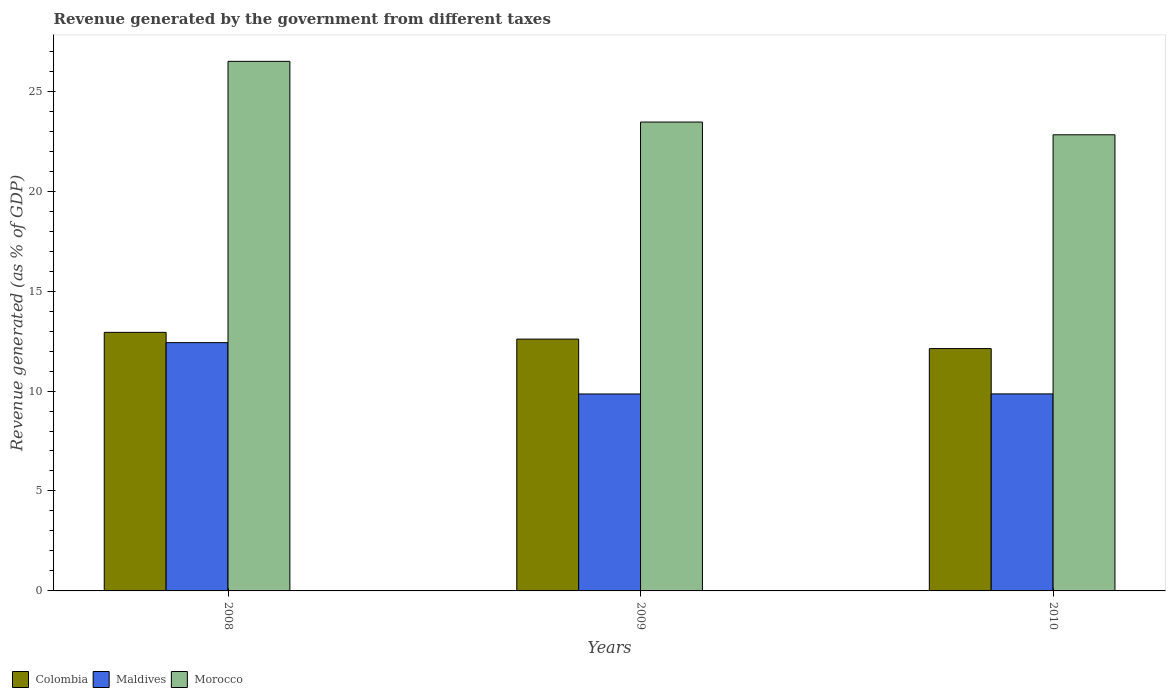How many different coloured bars are there?
Your answer should be very brief. 3. How many bars are there on the 2nd tick from the left?
Offer a very short reply. 3. How many bars are there on the 1st tick from the right?
Give a very brief answer. 3. What is the label of the 3rd group of bars from the left?
Your answer should be compact. 2010. In how many cases, is the number of bars for a given year not equal to the number of legend labels?
Ensure brevity in your answer.  0. What is the revenue generated by the government in Colombia in 2008?
Give a very brief answer. 12.94. Across all years, what is the maximum revenue generated by the government in Colombia?
Provide a short and direct response. 12.94. Across all years, what is the minimum revenue generated by the government in Morocco?
Your answer should be very brief. 22.82. What is the total revenue generated by the government in Morocco in the graph?
Offer a very short reply. 72.77. What is the difference between the revenue generated by the government in Colombia in 2008 and that in 2010?
Keep it short and to the point. 0.81. What is the difference between the revenue generated by the government in Morocco in 2008 and the revenue generated by the government in Maldives in 2009?
Give a very brief answer. 16.64. What is the average revenue generated by the government in Colombia per year?
Keep it short and to the point. 12.55. In the year 2010, what is the difference between the revenue generated by the government in Morocco and revenue generated by the government in Maldives?
Make the answer very short. 12.96. What is the ratio of the revenue generated by the government in Colombia in 2009 to that in 2010?
Your answer should be very brief. 1.04. Is the difference between the revenue generated by the government in Morocco in 2009 and 2010 greater than the difference between the revenue generated by the government in Maldives in 2009 and 2010?
Provide a short and direct response. Yes. What is the difference between the highest and the second highest revenue generated by the government in Morocco?
Your response must be concise. 3.04. What is the difference between the highest and the lowest revenue generated by the government in Morocco?
Keep it short and to the point. 3.67. What does the 2nd bar from the left in 2009 represents?
Provide a succinct answer. Maldives. What does the 1st bar from the right in 2009 represents?
Your response must be concise. Morocco. Is it the case that in every year, the sum of the revenue generated by the government in Maldives and revenue generated by the government in Colombia is greater than the revenue generated by the government in Morocco?
Provide a succinct answer. No. How many bars are there?
Your response must be concise. 9. Does the graph contain grids?
Provide a succinct answer. No. How many legend labels are there?
Make the answer very short. 3. What is the title of the graph?
Provide a succinct answer. Revenue generated by the government from different taxes. Does "St. Vincent and the Grenadines" appear as one of the legend labels in the graph?
Your response must be concise. No. What is the label or title of the Y-axis?
Your answer should be compact. Revenue generated (as % of GDP). What is the Revenue generated (as % of GDP) in Colombia in 2008?
Provide a short and direct response. 12.94. What is the Revenue generated (as % of GDP) in Maldives in 2008?
Offer a very short reply. 12.42. What is the Revenue generated (as % of GDP) in Morocco in 2008?
Provide a succinct answer. 26.49. What is the Revenue generated (as % of GDP) in Colombia in 2009?
Give a very brief answer. 12.6. What is the Revenue generated (as % of GDP) of Maldives in 2009?
Your answer should be compact. 9.85. What is the Revenue generated (as % of GDP) of Morocco in 2009?
Your answer should be very brief. 23.46. What is the Revenue generated (as % of GDP) in Colombia in 2010?
Provide a short and direct response. 12.12. What is the Revenue generated (as % of GDP) of Maldives in 2010?
Offer a very short reply. 9.86. What is the Revenue generated (as % of GDP) of Morocco in 2010?
Your answer should be compact. 22.82. Across all years, what is the maximum Revenue generated (as % of GDP) of Colombia?
Offer a terse response. 12.94. Across all years, what is the maximum Revenue generated (as % of GDP) of Maldives?
Provide a short and direct response. 12.42. Across all years, what is the maximum Revenue generated (as % of GDP) in Morocco?
Your answer should be compact. 26.49. Across all years, what is the minimum Revenue generated (as % of GDP) in Colombia?
Your response must be concise. 12.12. Across all years, what is the minimum Revenue generated (as % of GDP) in Maldives?
Offer a very short reply. 9.85. Across all years, what is the minimum Revenue generated (as % of GDP) in Morocco?
Offer a terse response. 22.82. What is the total Revenue generated (as % of GDP) of Colombia in the graph?
Your answer should be compact. 37.66. What is the total Revenue generated (as % of GDP) of Maldives in the graph?
Provide a short and direct response. 32.13. What is the total Revenue generated (as % of GDP) in Morocco in the graph?
Offer a terse response. 72.77. What is the difference between the Revenue generated (as % of GDP) in Colombia in 2008 and that in 2009?
Your answer should be compact. 0.34. What is the difference between the Revenue generated (as % of GDP) in Maldives in 2008 and that in 2009?
Give a very brief answer. 2.57. What is the difference between the Revenue generated (as % of GDP) of Morocco in 2008 and that in 2009?
Make the answer very short. 3.04. What is the difference between the Revenue generated (as % of GDP) in Colombia in 2008 and that in 2010?
Ensure brevity in your answer.  0.81. What is the difference between the Revenue generated (as % of GDP) of Maldives in 2008 and that in 2010?
Offer a terse response. 2.56. What is the difference between the Revenue generated (as % of GDP) in Morocco in 2008 and that in 2010?
Give a very brief answer. 3.67. What is the difference between the Revenue generated (as % of GDP) of Colombia in 2009 and that in 2010?
Your answer should be compact. 0.48. What is the difference between the Revenue generated (as % of GDP) in Maldives in 2009 and that in 2010?
Provide a succinct answer. -0. What is the difference between the Revenue generated (as % of GDP) in Morocco in 2009 and that in 2010?
Ensure brevity in your answer.  0.64. What is the difference between the Revenue generated (as % of GDP) of Colombia in 2008 and the Revenue generated (as % of GDP) of Maldives in 2009?
Provide a succinct answer. 3.08. What is the difference between the Revenue generated (as % of GDP) in Colombia in 2008 and the Revenue generated (as % of GDP) in Morocco in 2009?
Keep it short and to the point. -10.52. What is the difference between the Revenue generated (as % of GDP) of Maldives in 2008 and the Revenue generated (as % of GDP) of Morocco in 2009?
Your answer should be compact. -11.04. What is the difference between the Revenue generated (as % of GDP) of Colombia in 2008 and the Revenue generated (as % of GDP) of Maldives in 2010?
Make the answer very short. 3.08. What is the difference between the Revenue generated (as % of GDP) of Colombia in 2008 and the Revenue generated (as % of GDP) of Morocco in 2010?
Your response must be concise. -9.88. What is the difference between the Revenue generated (as % of GDP) of Maldives in 2008 and the Revenue generated (as % of GDP) of Morocco in 2010?
Keep it short and to the point. -10.4. What is the difference between the Revenue generated (as % of GDP) in Colombia in 2009 and the Revenue generated (as % of GDP) in Maldives in 2010?
Your answer should be very brief. 2.74. What is the difference between the Revenue generated (as % of GDP) of Colombia in 2009 and the Revenue generated (as % of GDP) of Morocco in 2010?
Keep it short and to the point. -10.22. What is the difference between the Revenue generated (as % of GDP) of Maldives in 2009 and the Revenue generated (as % of GDP) of Morocco in 2010?
Provide a succinct answer. -12.97. What is the average Revenue generated (as % of GDP) in Colombia per year?
Keep it short and to the point. 12.55. What is the average Revenue generated (as % of GDP) of Maldives per year?
Keep it short and to the point. 10.71. What is the average Revenue generated (as % of GDP) of Morocco per year?
Your answer should be very brief. 24.26. In the year 2008, what is the difference between the Revenue generated (as % of GDP) in Colombia and Revenue generated (as % of GDP) in Maldives?
Your answer should be very brief. 0.52. In the year 2008, what is the difference between the Revenue generated (as % of GDP) in Colombia and Revenue generated (as % of GDP) in Morocco?
Offer a terse response. -13.56. In the year 2008, what is the difference between the Revenue generated (as % of GDP) of Maldives and Revenue generated (as % of GDP) of Morocco?
Give a very brief answer. -14.07. In the year 2009, what is the difference between the Revenue generated (as % of GDP) in Colombia and Revenue generated (as % of GDP) in Maldives?
Give a very brief answer. 2.75. In the year 2009, what is the difference between the Revenue generated (as % of GDP) of Colombia and Revenue generated (as % of GDP) of Morocco?
Give a very brief answer. -10.86. In the year 2009, what is the difference between the Revenue generated (as % of GDP) in Maldives and Revenue generated (as % of GDP) in Morocco?
Ensure brevity in your answer.  -13.6. In the year 2010, what is the difference between the Revenue generated (as % of GDP) in Colombia and Revenue generated (as % of GDP) in Maldives?
Provide a succinct answer. 2.27. In the year 2010, what is the difference between the Revenue generated (as % of GDP) in Colombia and Revenue generated (as % of GDP) in Morocco?
Provide a short and direct response. -10.7. In the year 2010, what is the difference between the Revenue generated (as % of GDP) in Maldives and Revenue generated (as % of GDP) in Morocco?
Your response must be concise. -12.96. What is the ratio of the Revenue generated (as % of GDP) in Colombia in 2008 to that in 2009?
Provide a succinct answer. 1.03. What is the ratio of the Revenue generated (as % of GDP) of Maldives in 2008 to that in 2009?
Your answer should be very brief. 1.26. What is the ratio of the Revenue generated (as % of GDP) of Morocco in 2008 to that in 2009?
Ensure brevity in your answer.  1.13. What is the ratio of the Revenue generated (as % of GDP) in Colombia in 2008 to that in 2010?
Provide a succinct answer. 1.07. What is the ratio of the Revenue generated (as % of GDP) of Maldives in 2008 to that in 2010?
Provide a short and direct response. 1.26. What is the ratio of the Revenue generated (as % of GDP) of Morocco in 2008 to that in 2010?
Your answer should be very brief. 1.16. What is the ratio of the Revenue generated (as % of GDP) in Colombia in 2009 to that in 2010?
Your answer should be compact. 1.04. What is the ratio of the Revenue generated (as % of GDP) in Morocco in 2009 to that in 2010?
Your response must be concise. 1.03. What is the difference between the highest and the second highest Revenue generated (as % of GDP) in Colombia?
Your response must be concise. 0.34. What is the difference between the highest and the second highest Revenue generated (as % of GDP) of Maldives?
Provide a succinct answer. 2.56. What is the difference between the highest and the second highest Revenue generated (as % of GDP) in Morocco?
Offer a very short reply. 3.04. What is the difference between the highest and the lowest Revenue generated (as % of GDP) in Colombia?
Your response must be concise. 0.81. What is the difference between the highest and the lowest Revenue generated (as % of GDP) of Maldives?
Your answer should be compact. 2.57. What is the difference between the highest and the lowest Revenue generated (as % of GDP) in Morocco?
Make the answer very short. 3.67. 